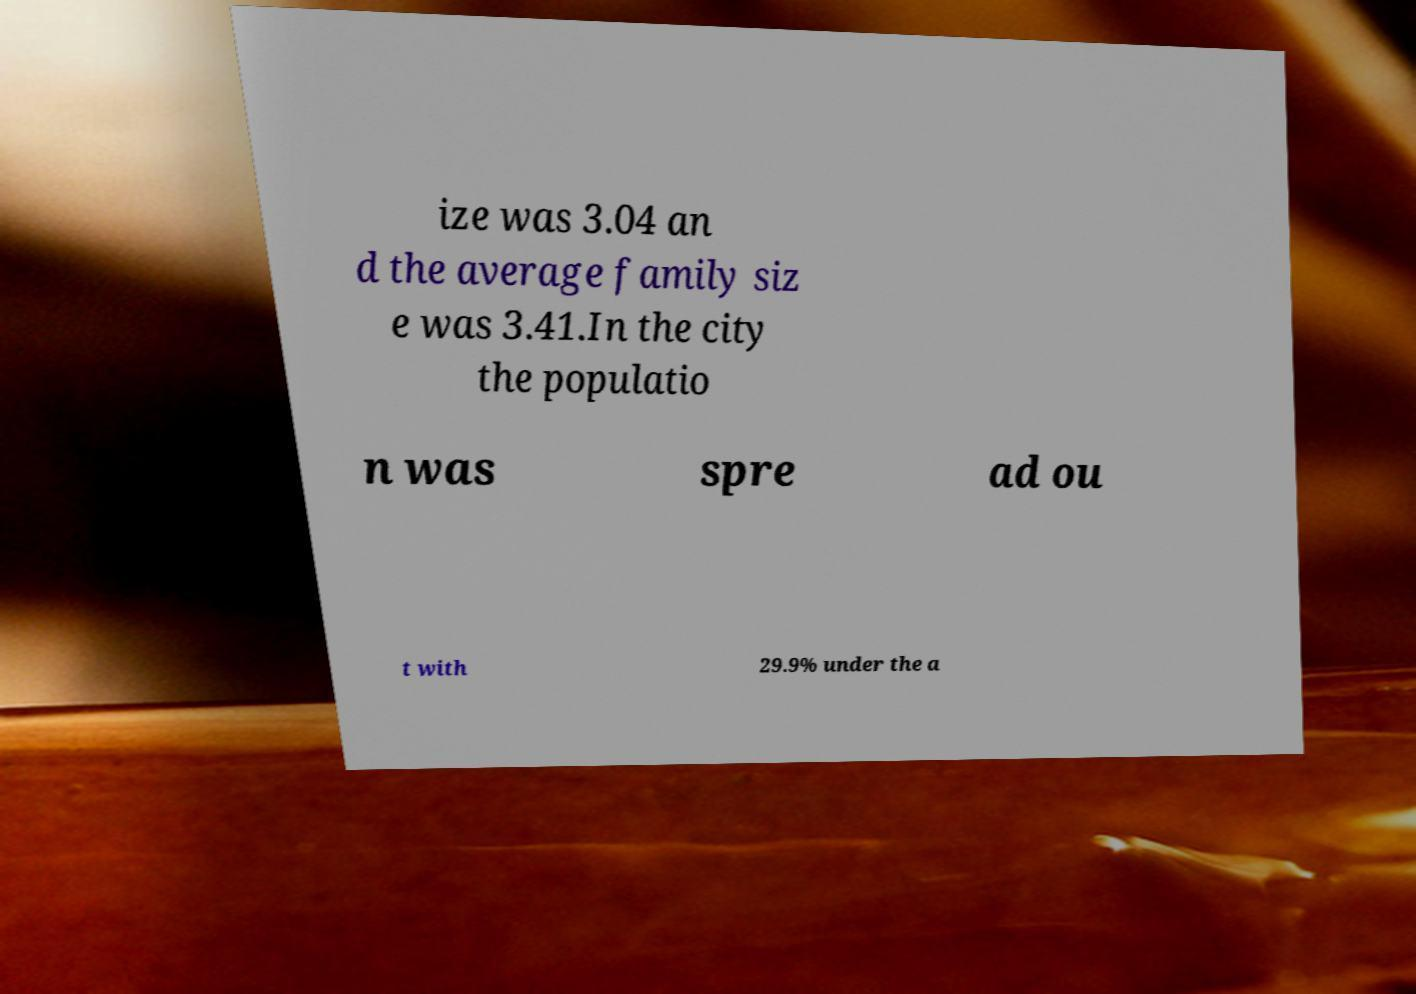For documentation purposes, I need the text within this image transcribed. Could you provide that? ize was 3.04 an d the average family siz e was 3.41.In the city the populatio n was spre ad ou t with 29.9% under the a 